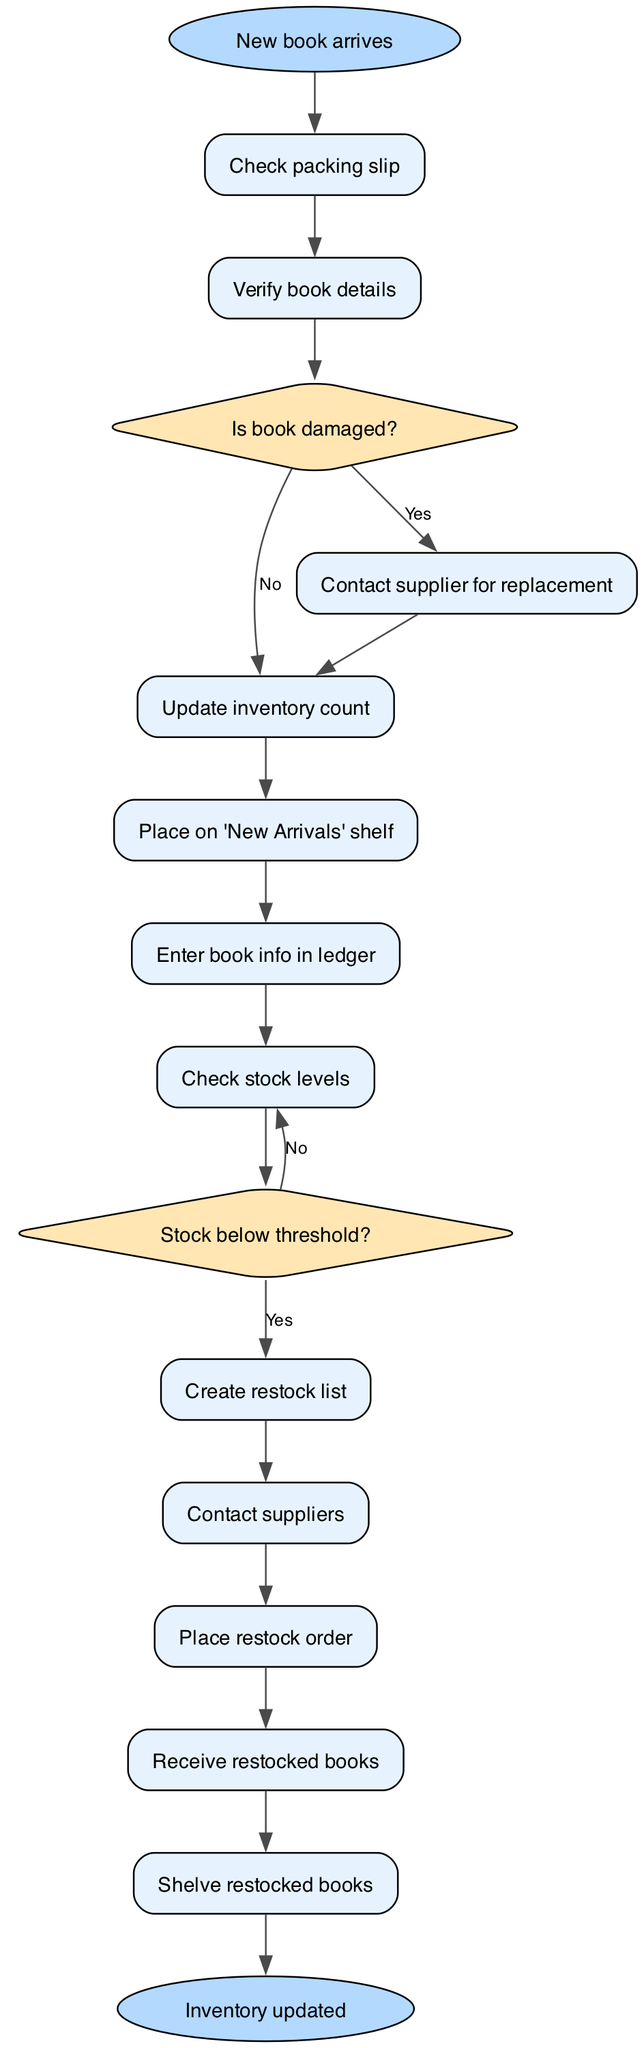What is the initial node in the diagram? The initial node is where the workflow starts, which here is labeled as "New book arrives."
Answer: New book arrives How many activities are there in the workflow? The activities are the steps involved in the workflow, and there are a total of ten listed in the diagram.
Answer: 10 What happens if the book is damaged? According to the diagram, if the book is damaged, the next step is to "Contact supplier for replacement."
Answer: Contact supplier for replacement What is the final node in the diagram? The final node signifies the end of the workflow, which is labeled as "Inventory updated."
Answer: Inventory updated How many decision points are present in the diagram? The diagram contains two decision points, each posing a question that affects the workflow.
Answer: 2 If stock is below threshold, what is the next action? If the stock levels are below the threshold, the next action is to "Add to restock list."
Answer: Add to restock list What activity follows after verifying book details? According to the flow of the diagram, the activity that follows verifying book details is "Update inventory count."
Answer: Update inventory count What can happen after checking the stock levels? After checking stock levels, there are two possible actions: if it’s below threshold, "Add to restock list," otherwise it goes back to "Continue monitoring."
Answer: Add to restock list or Continue monitoring What is the activity right before receiving restocked books? The activity that occurs immediately before receiving restocked books is "Place restock order."
Answer: Place restock order 